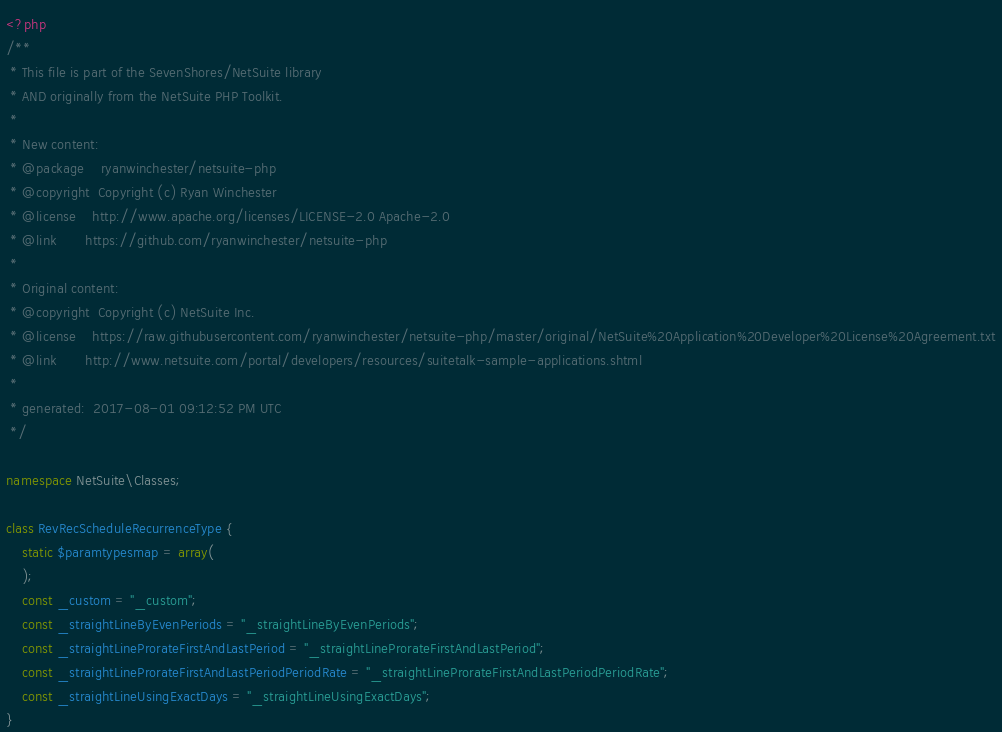Convert code to text. <code><loc_0><loc_0><loc_500><loc_500><_PHP_><?php
/**
 * This file is part of the SevenShores/NetSuite library
 * AND originally from the NetSuite PHP Toolkit.
 *
 * New content:
 * @package    ryanwinchester/netsuite-php
 * @copyright  Copyright (c) Ryan Winchester
 * @license    http://www.apache.org/licenses/LICENSE-2.0 Apache-2.0
 * @link       https://github.com/ryanwinchester/netsuite-php
 *
 * Original content:
 * @copyright  Copyright (c) NetSuite Inc.
 * @license    https://raw.githubusercontent.com/ryanwinchester/netsuite-php/master/original/NetSuite%20Application%20Developer%20License%20Agreement.txt
 * @link       http://www.netsuite.com/portal/developers/resources/suitetalk-sample-applications.shtml
 *
 * generated:  2017-08-01 09:12:52 PM UTC
 */

namespace NetSuite\Classes;

class RevRecScheduleRecurrenceType {
    static $paramtypesmap = array(
    );
    const _custom = "_custom";
    const _straightLineByEvenPeriods = "_straightLineByEvenPeriods";
    const _straightLineProrateFirstAndLastPeriod = "_straightLineProrateFirstAndLastPeriod";
    const _straightLineProrateFirstAndLastPeriodPeriodRate = "_straightLineProrateFirstAndLastPeriodPeriodRate";
    const _straightLineUsingExactDays = "_straightLineUsingExactDays";
}
</code> 